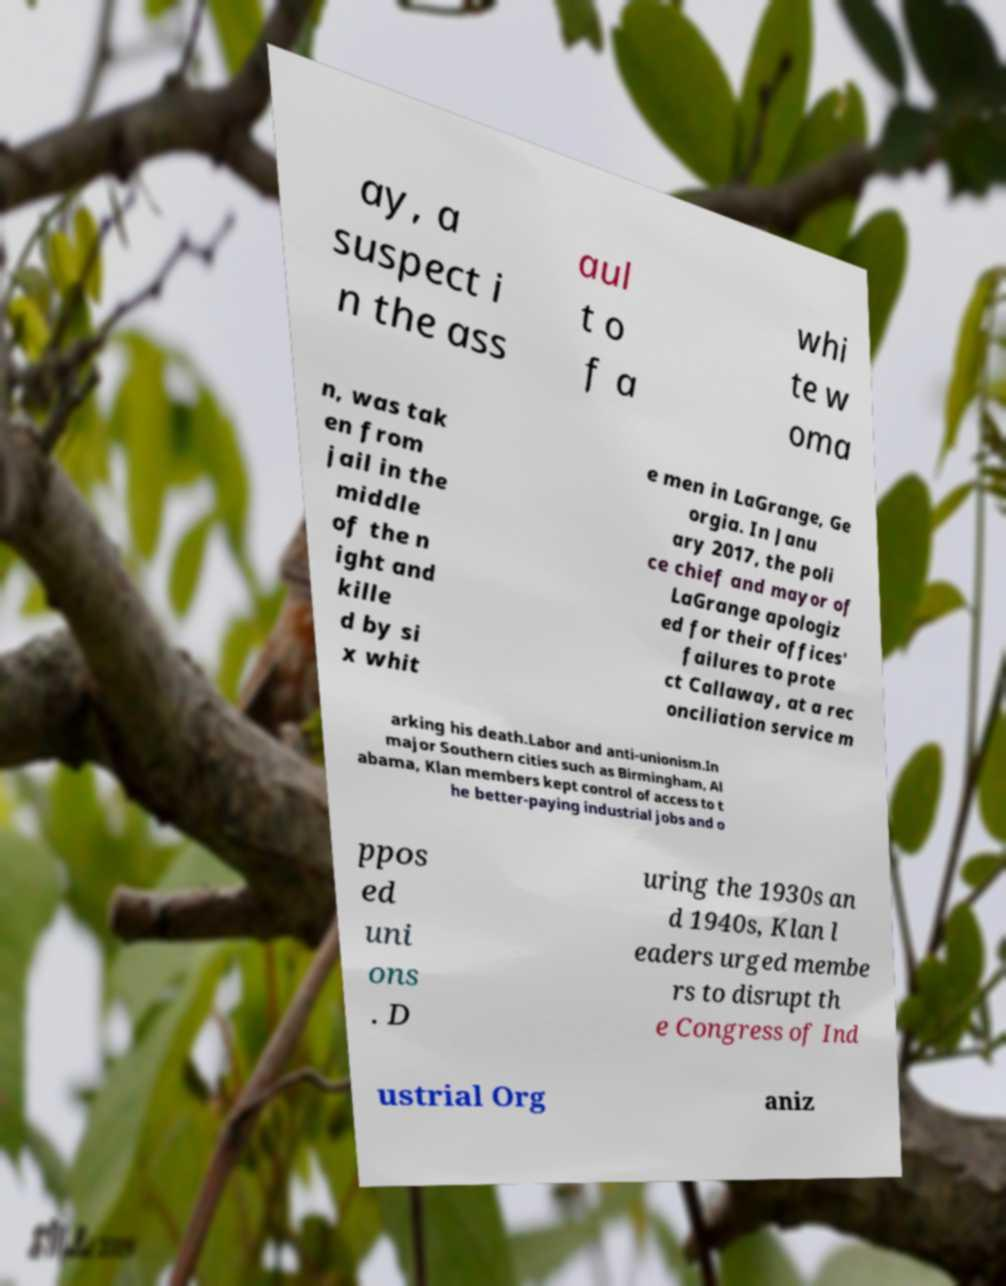Please identify and transcribe the text found in this image. ay, a suspect i n the ass aul t o f a whi te w oma n, was tak en from jail in the middle of the n ight and kille d by si x whit e men in LaGrange, Ge orgia. In Janu ary 2017, the poli ce chief and mayor of LaGrange apologiz ed for their offices' failures to prote ct Callaway, at a rec onciliation service m arking his death.Labor and anti-unionism.In major Southern cities such as Birmingham, Al abama, Klan members kept control of access to t he better-paying industrial jobs and o ppos ed uni ons . D uring the 1930s an d 1940s, Klan l eaders urged membe rs to disrupt th e Congress of Ind ustrial Org aniz 